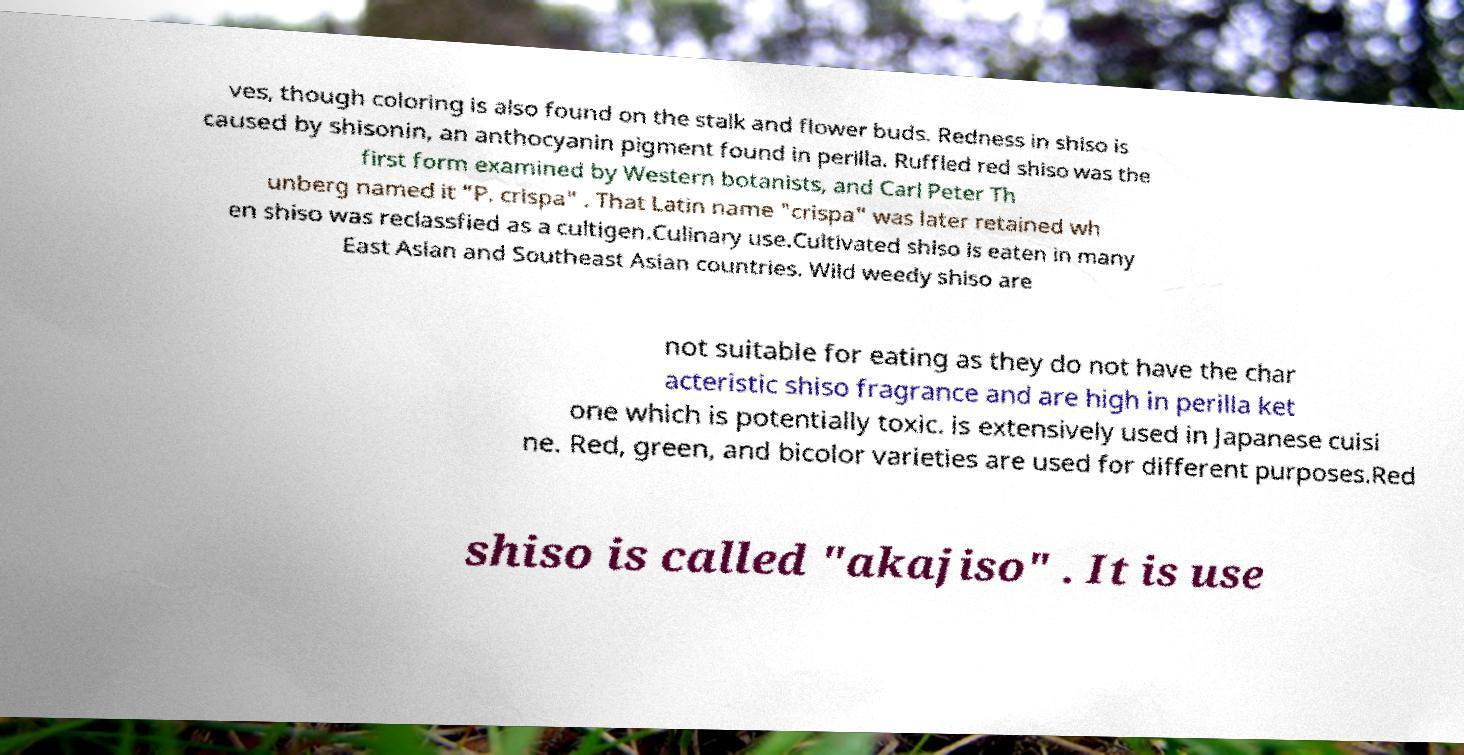Please read and relay the text visible in this image. What does it say? ves, though coloring is also found on the stalk and flower buds. Redness in shiso is caused by shisonin, an anthocyanin pigment found in perilla. Ruffled red shiso was the first form examined by Western botanists, and Carl Peter Th unberg named it "P. crispa" . That Latin name "crispa" was later retained wh en shiso was reclassfied as a cultigen.Culinary use.Cultivated shiso is eaten in many East Asian and Southeast Asian countries. Wild weedy shiso are not suitable for eating as they do not have the char acteristic shiso fragrance and are high in perilla ket one which is potentially toxic. is extensively used in Japanese cuisi ne. Red, green, and bicolor varieties are used for different purposes.Red shiso is called "akajiso" . It is use 